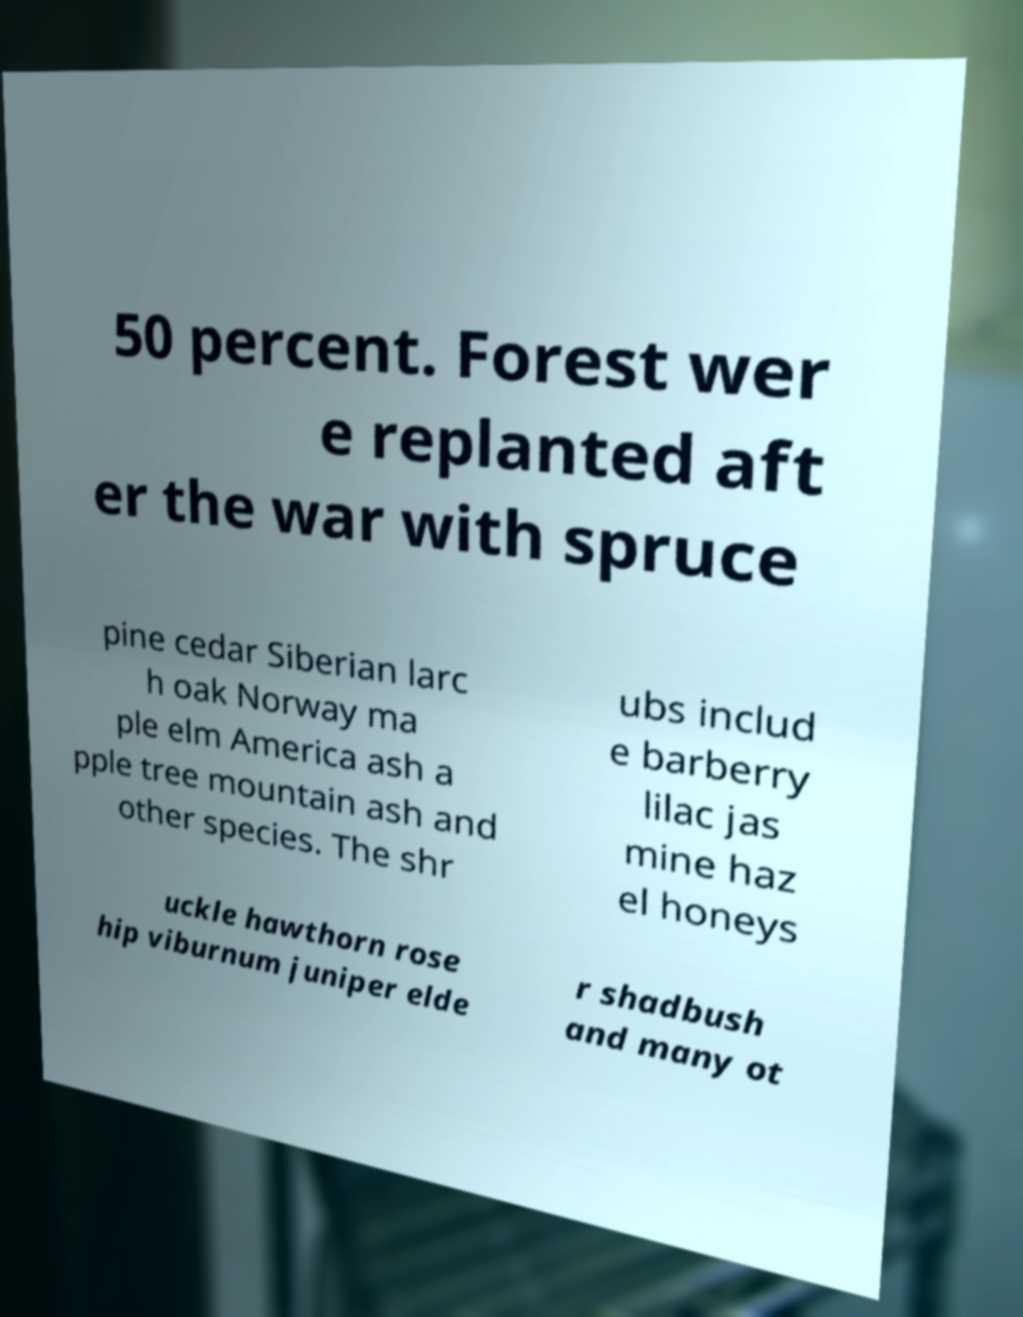There's text embedded in this image that I need extracted. Can you transcribe it verbatim? 50 percent. Forest wer e replanted aft er the war with spruce pine cedar Siberian larc h oak Norway ma ple elm America ash a pple tree mountain ash and other species. The shr ubs includ e barberry lilac jas mine haz el honeys uckle hawthorn rose hip viburnum juniper elde r shadbush and many ot 